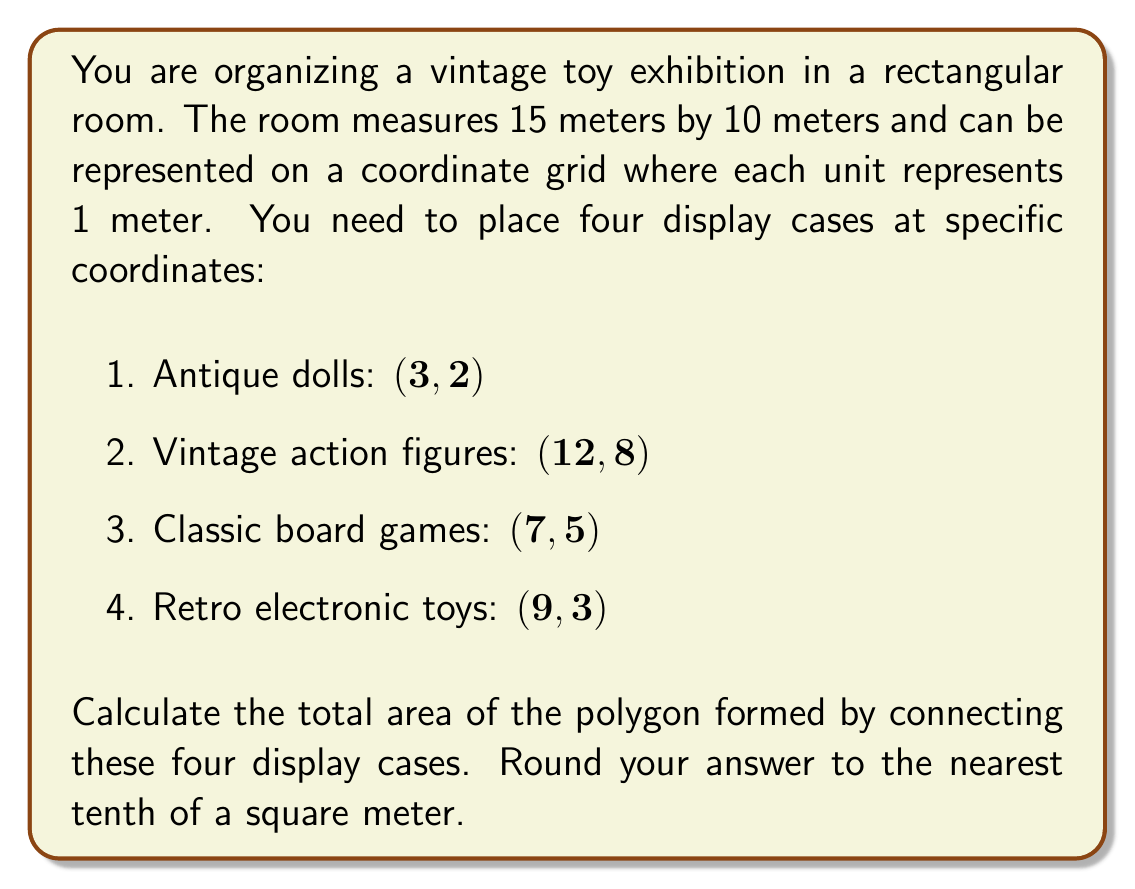Can you answer this question? To solve this problem, we need to follow these steps:

1. Plot the points on a coordinate grid.
2. Connect the points to form a polygon.
3. Divide the polygon into triangles.
4. Calculate the area of each triangle.
5. Sum the areas of all triangles to get the total area.

Let's begin:

1. Plot the points:
   $(3, 2)$, $(12, 8)$, $(7, 5)$, $(9, 3)$

2. Connect the points to form a quadrilateral.

3. Divide the quadrilateral into two triangles:
   Triangle 1: $(3, 2)$, $(12, 8)$, $(7, 5)$
   Triangle 2: $(3, 2)$, $(9, 3)$, $(7, 5)$

4. Calculate the area of each triangle using the formula:
   $$A = \frac{1}{2}|x_1(y_2 - y_3) + x_2(y_3 - y_1) + x_3(y_1 - y_2)|$$

   For Triangle 1:
   $$A_1 = \frac{1}{2}|3(8 - 5) + 12(5 - 2) + 7(2 - 8)|$$
   $$A_1 = \frac{1}{2}|3(3) + 12(3) + 7(-6)|$$
   $$A_1 = \frac{1}{2}|9 + 36 - 42| = \frac{1}{2}(3) = 1.5$$

   For Triangle 2:
   $$A_2 = \frac{1}{2}|3(3 - 5) + 9(5 - 2) + 7(2 - 3)|$$
   $$A_2 = \frac{1}{2}|3(-2) + 9(3) + 7(-1)|$$
   $$A_2 = \frac{1}{2}|-6 + 27 - 7| = \frac{1}{2}(14) = 7$$

5. Sum the areas of both triangles:
   $$A_{total} = A_1 + A_2 = 1.5 + 7 = 8.5$$

Therefore, the total area of the polygon is 8.5 square meters.
Answer: 8.5 square meters 